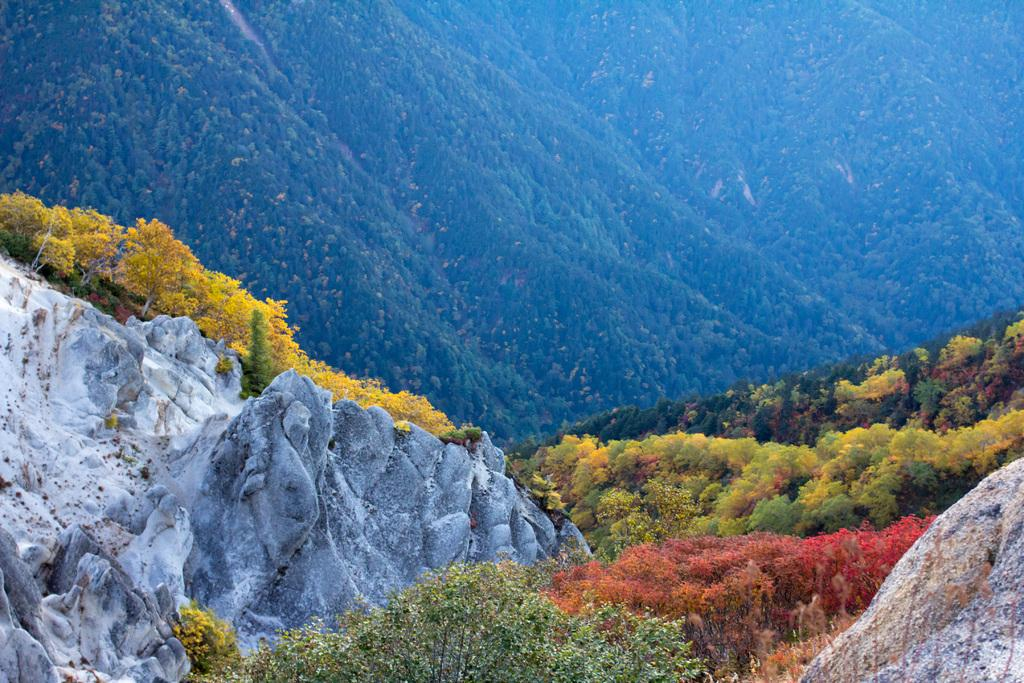What is the main feature of the image? The main feature of the image is the huge rocks. What else can be seen around the rocks? There are beautiful trees around the rocks. What is visible in the background of the image? There is a mountain in the background of the image. What type of company is depicted in the image? There is no company present in the image; it features natural elements such as rocks, trees, and a mountain. What color is the stocking hanging on the tree in the image? There is no stocking present in the image; it features natural elements such as rocks, trees, and a mountain. 